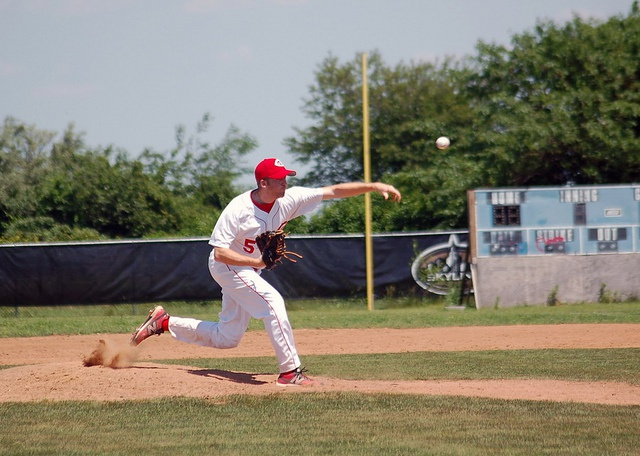Describe the objects in this image and their specific colors. I can see people in darkgray, white, brown, and lightpink tones, baseball glove in darkgray, black, maroon, brown, and gray tones, and sports ball in darkgray, ivory, and gray tones in this image. 